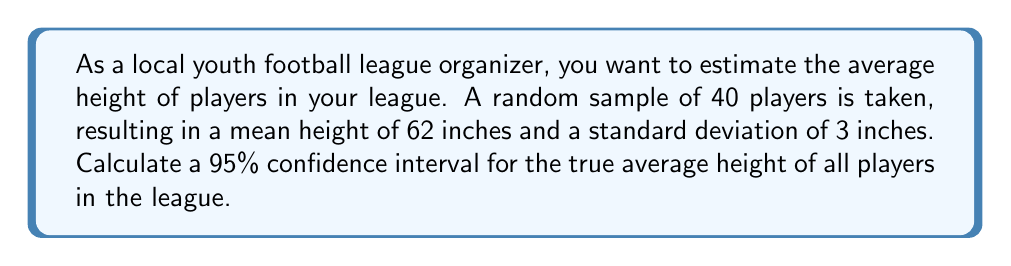Can you solve this math problem? To calculate the confidence interval, we'll follow these steps:

1. Identify the given information:
   - Sample size: $n = 40$
   - Sample mean: $\bar{x} = 62$ inches
   - Sample standard deviation: $s = 3$ inches
   - Confidence level: 95%

2. Determine the critical value:
   For a 95% confidence interval with df = 39, the t-critical value is approximately 2.023.

3. Calculate the margin of error:
   $\text{Margin of Error} = t_{\text{critical}} \cdot \frac{s}{\sqrt{n}}$
   $\text{Margin of Error} = 2.023 \cdot \frac{3}{\sqrt{40}} = 2.023 \cdot 0.4743 \approx 0.96$ inches

4. Construct the confidence interval:
   $\text{CI} = \bar{x} \pm \text{Margin of Error}$
   $\text{CI} = 62 \pm 0.96$
   
   Lower bound: $62 - 0.96 = 61.04$ inches
   Upper bound: $62 + 0.96 = 62.96$ inches

Therefore, we can be 95% confident that the true average height of all players in the league falls between 61.04 inches and 62.96 inches.
Answer: (61.04, 62.96) inches 